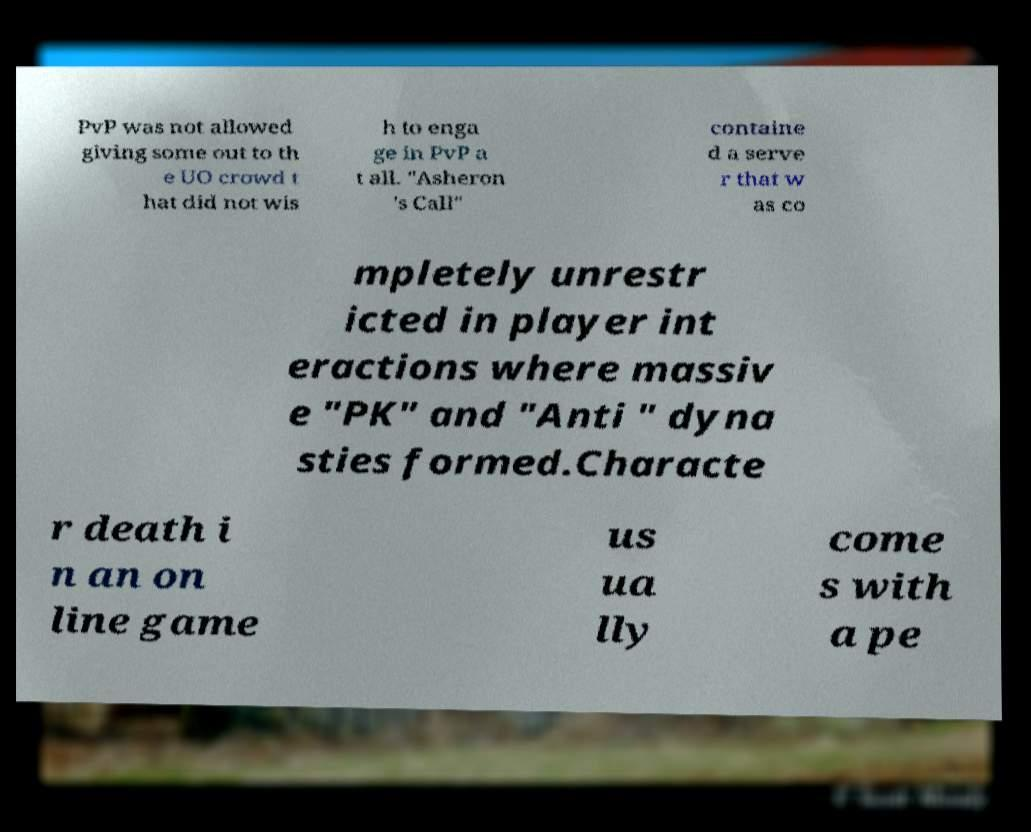Can you read and provide the text displayed in the image?This photo seems to have some interesting text. Can you extract and type it out for me? PvP was not allowed giving some out to th e UO crowd t hat did not wis h to enga ge in PvP a t all. "Asheron 's Call" containe d a serve r that w as co mpletely unrestr icted in player int eractions where massiv e "PK" and "Anti " dyna sties formed.Characte r death i n an on line game us ua lly come s with a pe 